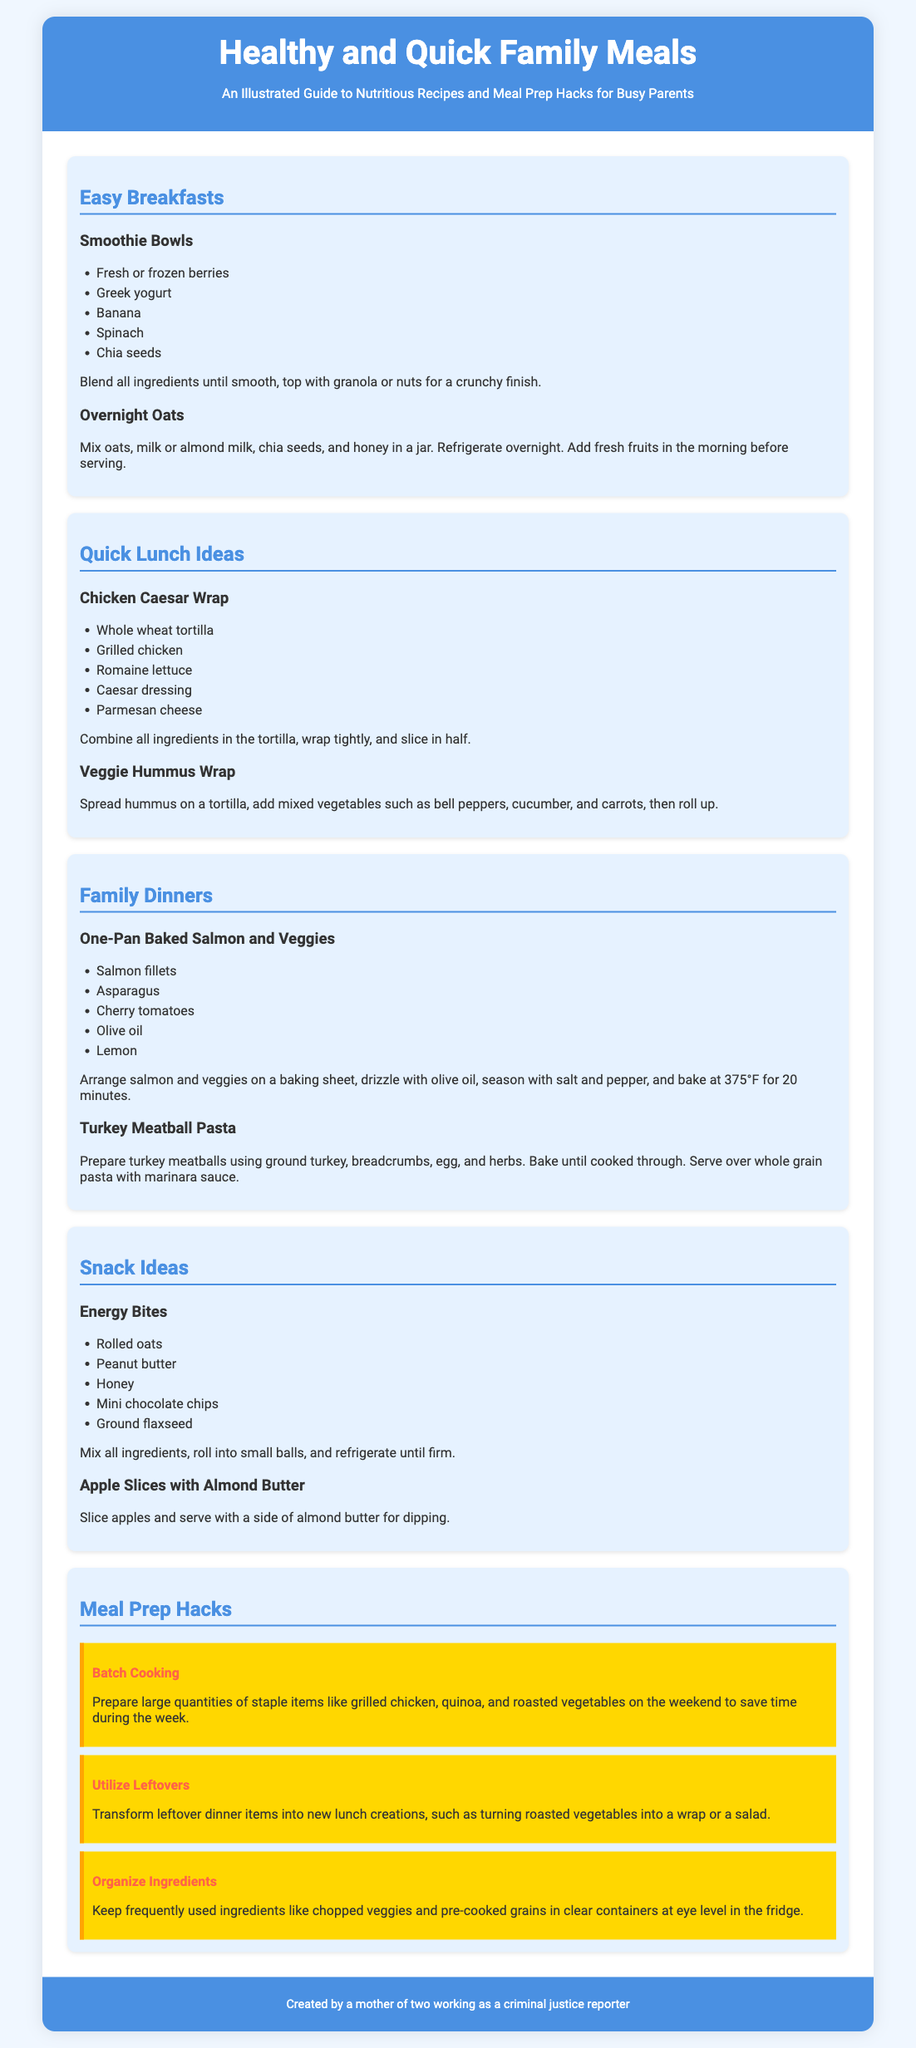What are the ingredients for Smoothie Bowls? The ingredients for Smoothie Bowls are listed in the section about Easy Breakfasts.
Answer: Fresh or frozen berries, Greek yogurt, banana, spinach, chia seeds What is the cooking temperature for the One-Pan Baked Salmon and Veggies? The cooking temperature is mentioned in the Family Dinners section.
Answer: 375°F How many types of snacks are listed in the document? There are two snack ideas mentioned in the Snack Ideas section.
Answer: 2 What is a meal prep hack related to using leftovers? The meal prep hack concerning leftovers is found in the Meal Prep Hacks section.
Answer: Transform leftover dinner items into new lunch creations What is one ingredient used in Energy Bites? An ingredient used in Energy Bites is listed in the Snack Ideas section.
Answer: Peanut butter What is the title of the guide? The title of the poster is displayed prominently in the header.
Answer: Healthy and Quick Family Meals 